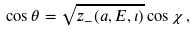<formula> <loc_0><loc_0><loc_500><loc_500>\cos \theta = \sqrt { z _ { - } ( a , E , \iota ) } \cos \chi \, ,</formula> 